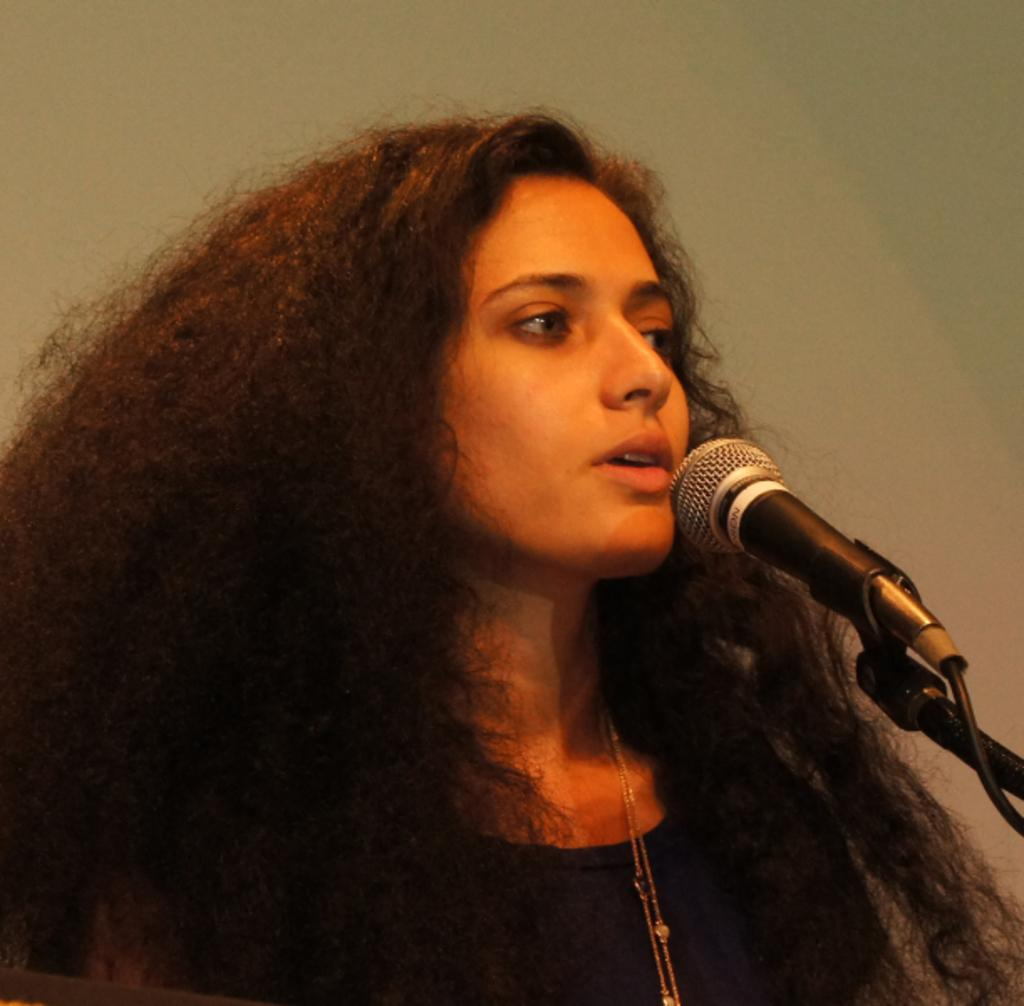Who is the main subject in the image? There is a woman in the image. What is the woman doing in the image? The woman is singing. What object is present that is typically used for amplifying the voice? There is a microphone with a stand in the image. What can be seen connected to the microphone? There is a wire visible in the image. What is the color of the background in the image? The background of the image is white. What type of door can be seen in the image? There is no door present in the image. How old is the baby in the image? There is no baby present in the image. 